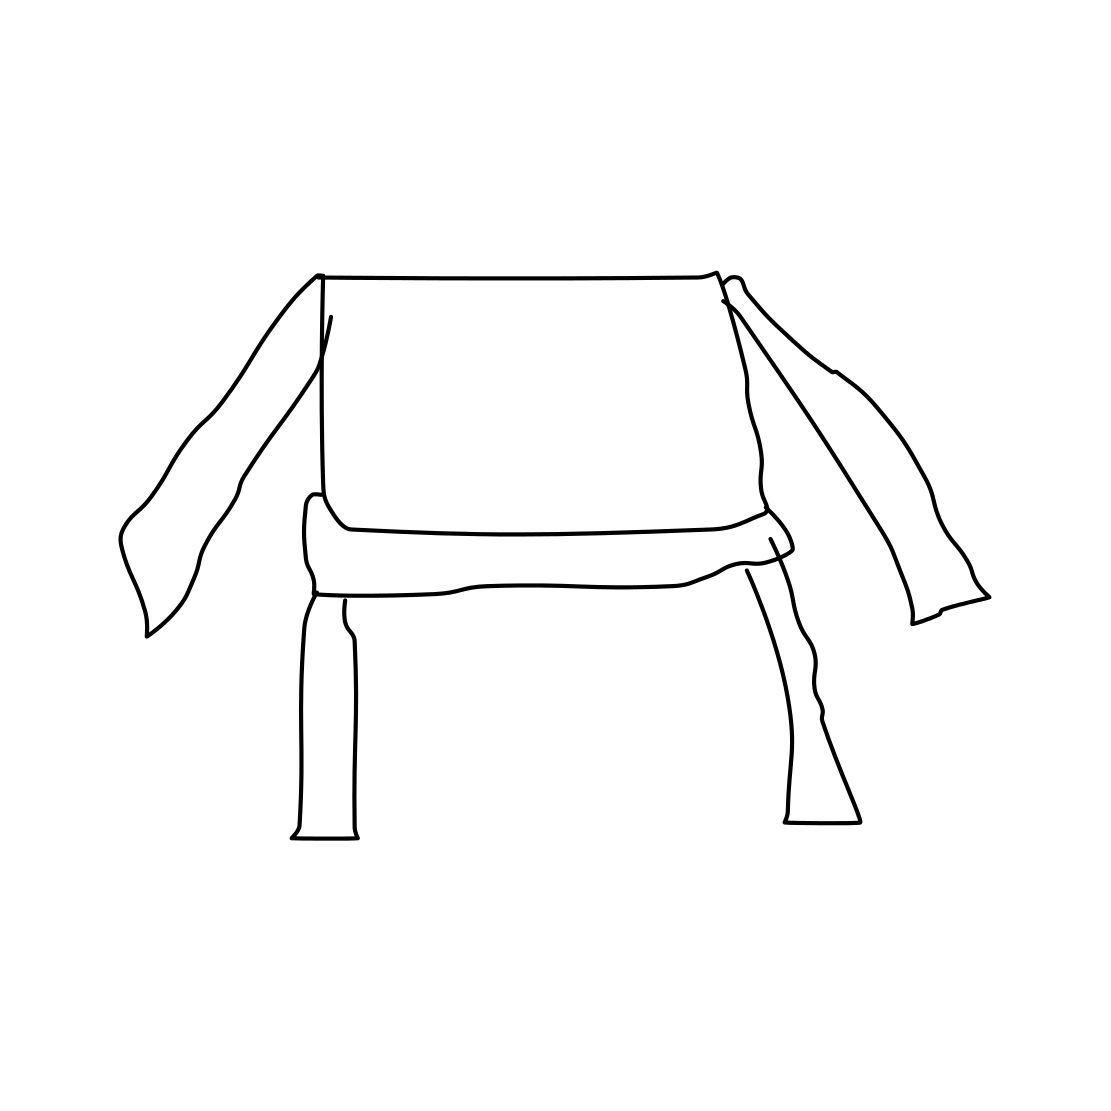What style does this drawing represent? The drawing represents an abstract or minimalist style, characterized by its clean lines and absence of unnecessary detail, emphasizing a simplistic form and structure. 